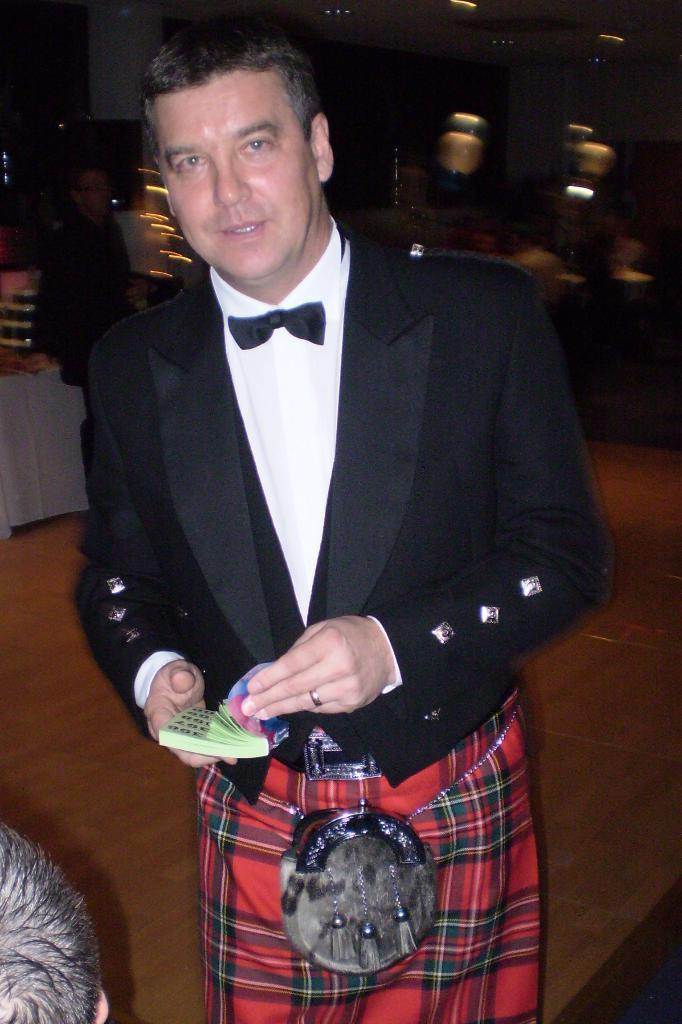Who is present in the image? There is a person in the image. What is the person wearing? The person is wearing a black coat. What is the person standing on? The person is standing on the ground. What is the person holding in their hand? The person is holding a book in their hand. What type of writing is the person arguing about in the image? There is no writing or argument present in the image; it only shows a person standing on the ground and holding a book. 